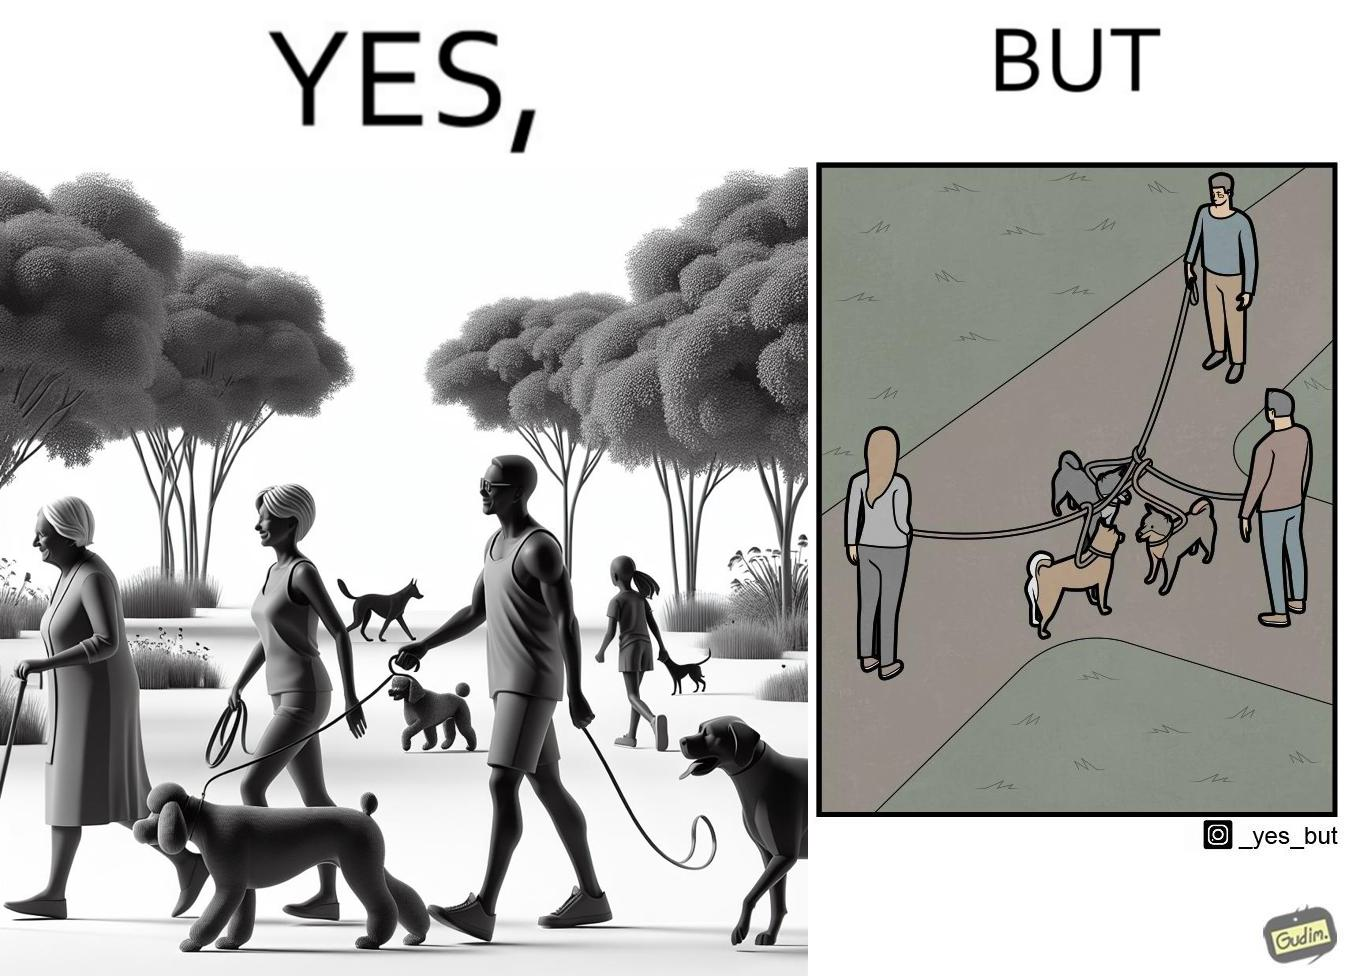Is this image satirical or non-satirical? Yes, this image is satirical. 